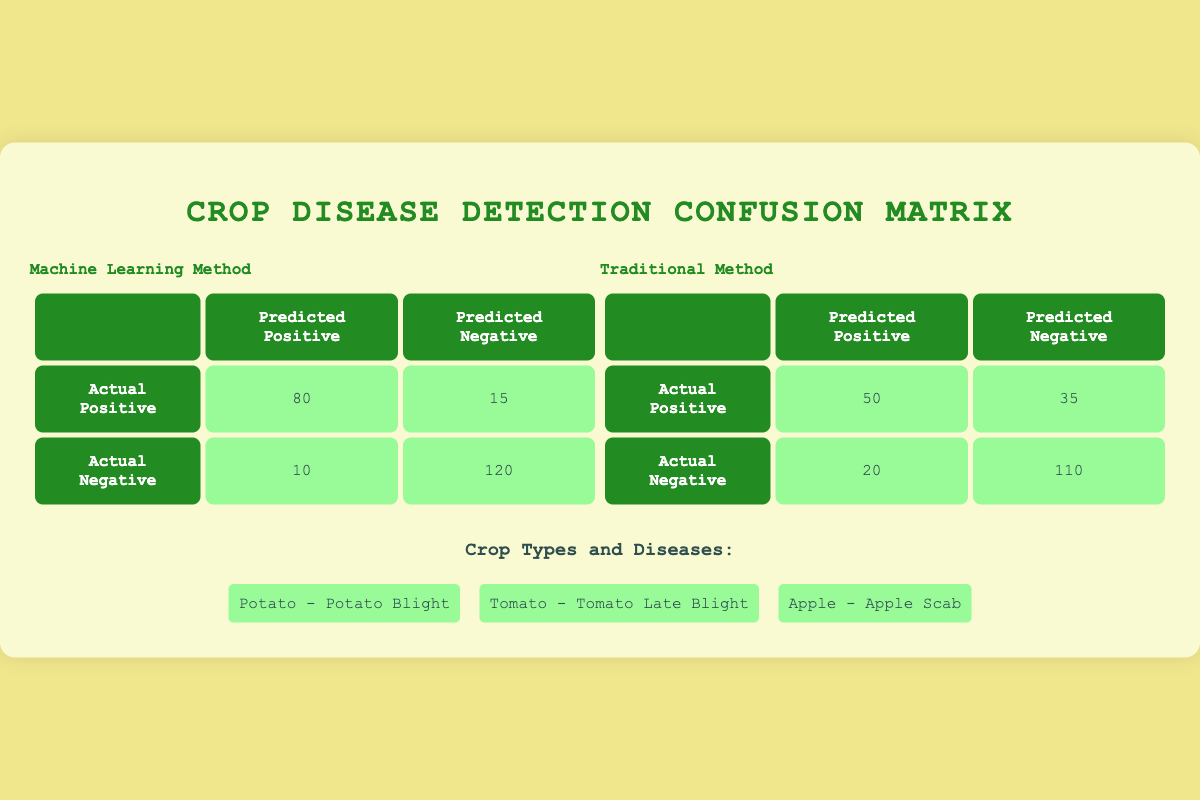What is the true positive rate for the machine learning method? The true positive rate, also known as sensitivity or recall, is calculated by dividing the true positives by the sum of true positives and false negatives. For the machine learning method, the true positives are 80 and the false negatives are 15. Thus, the calculation is 80 / (80 + 15) = 80 / 95 = 0.8421 or approximately 84.21%.
Answer: 84.21% How many actual negatives were identified correctly by the traditional method? The number of actual negatives identified correctly refers to the true negatives in the traditional method, which is directly given in the table. The value is 110.
Answer: 110 What is the total number of misclassifications made by the machine learning method? Misclassifications consist of both false positives and false negatives. For the machine learning method, the false positives are 10 and the false negatives are 15. Therefore, the total misclassifications are 10 + 15 = 25.
Answer: 25 Which method has a higher false negative count? The false negative count for the machine learning method is 15, while for the traditional method it is 35. Since 35 is greater than 15, the traditional method has a higher false negative count.
Answer: Traditional method Is it true that the machine learning method has a higher overall accuracy than the traditional method? Overall accuracy is calculated as (true positives + true negatives) / total cases. For machine learning, accuracy is (80 + 120) / (80 + 120 + 10 + 15) = 200 / 225 ≈ 0.8889 or 88.89%. For the traditional method, accuracy is (50 + 110) / (50 + 110 + 20 + 35) = 160 / 215 ≈ 0.7442 or 74.42%. Since 88.89% is higher than 74.42%, it is true that the machine learning method has a higher overall accuracy.
Answer: True What is the difference in true positives between the two methods? The true positives for the machine learning method are 80, while for the traditional method they are 50. To find the difference, we subtract 50 from 80, which gives us 80 - 50 = 30.
Answer: 30 